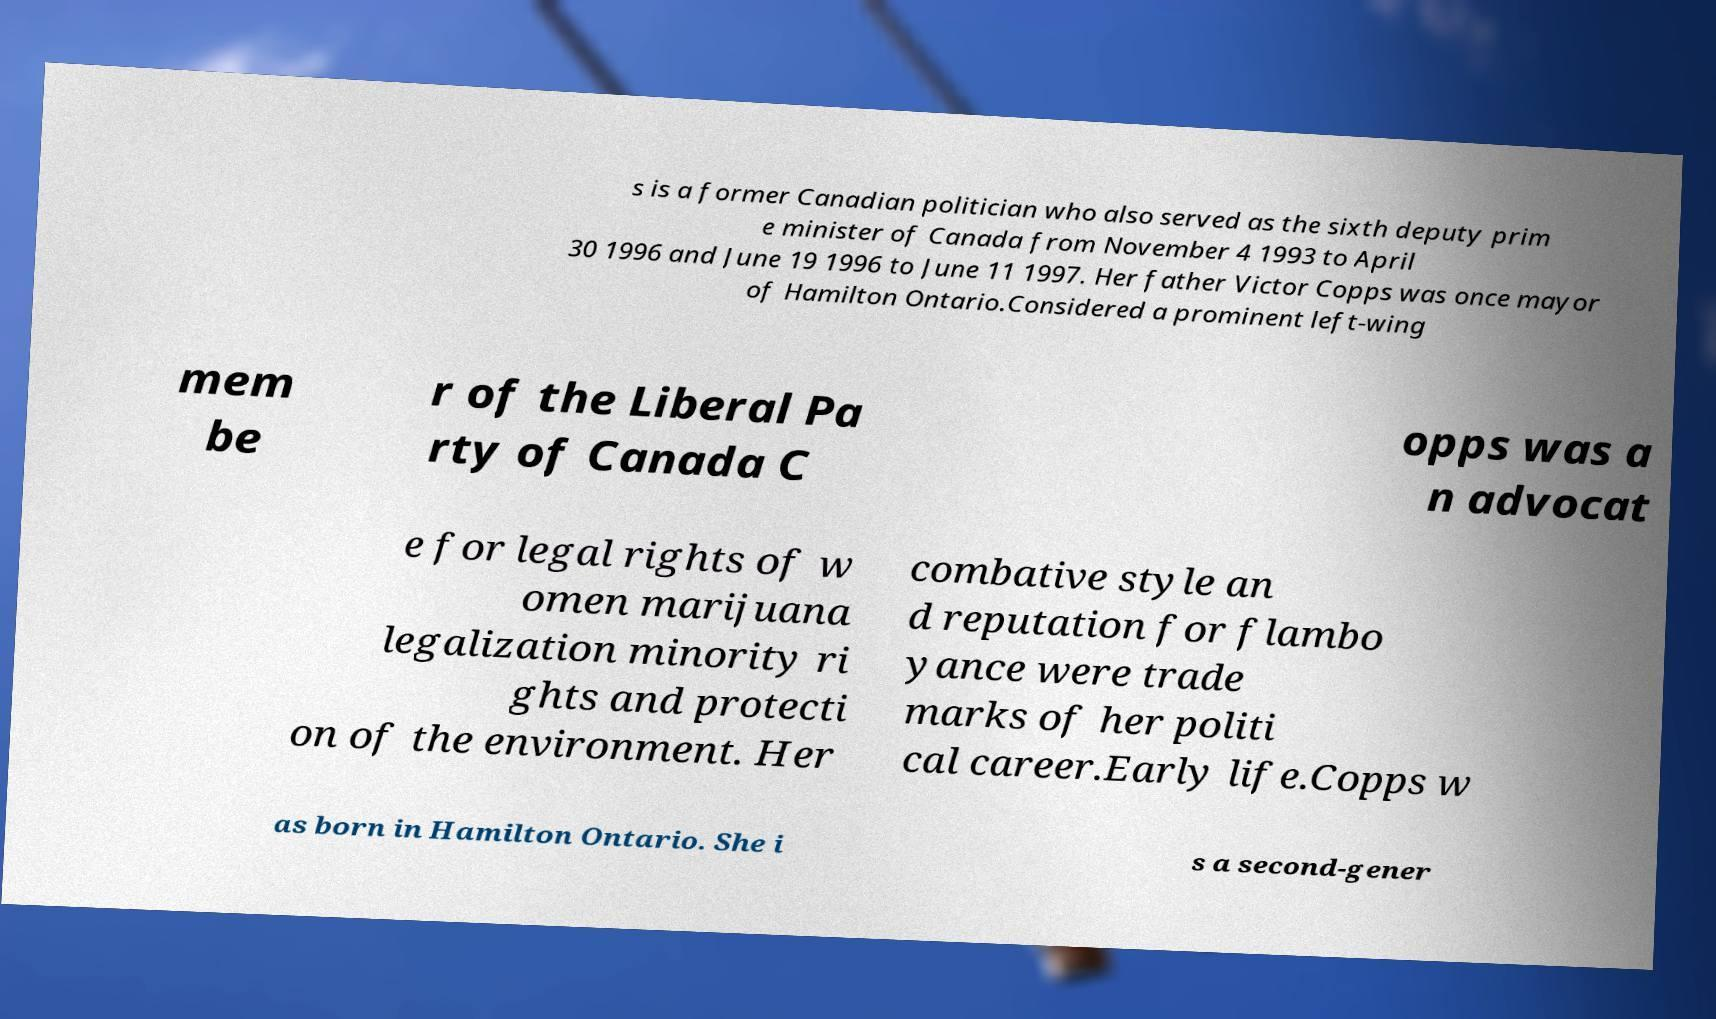I need the written content from this picture converted into text. Can you do that? s is a former Canadian politician who also served as the sixth deputy prim e minister of Canada from November 4 1993 to April 30 1996 and June 19 1996 to June 11 1997. Her father Victor Copps was once mayor of Hamilton Ontario.Considered a prominent left-wing mem be r of the Liberal Pa rty of Canada C opps was a n advocat e for legal rights of w omen marijuana legalization minority ri ghts and protecti on of the environment. Her combative style an d reputation for flambo yance were trade marks of her politi cal career.Early life.Copps w as born in Hamilton Ontario. She i s a second-gener 